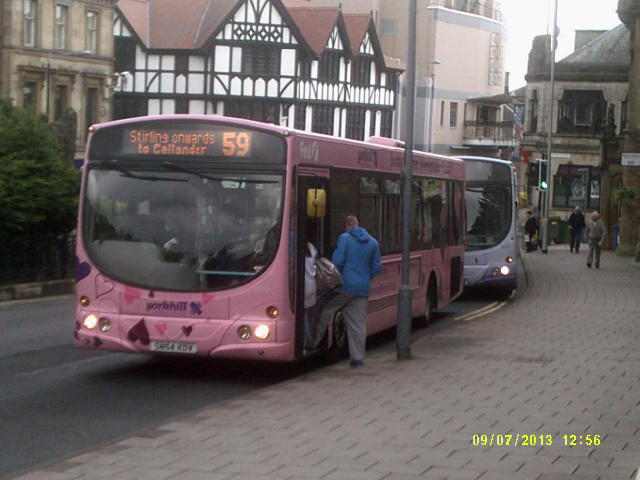Identify the text displayed in this image. 59 ONWARDS Caliander 12:56 2013 07 O g Norbhill 